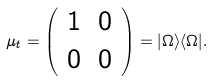Convert formula to latex. <formula><loc_0><loc_0><loc_500><loc_500>\mu _ { t } = \left ( \begin{array} { c c } 1 & 0 \\ 0 & 0 \end{array} \right ) = | \Omega \rangle \langle \Omega | .</formula> 